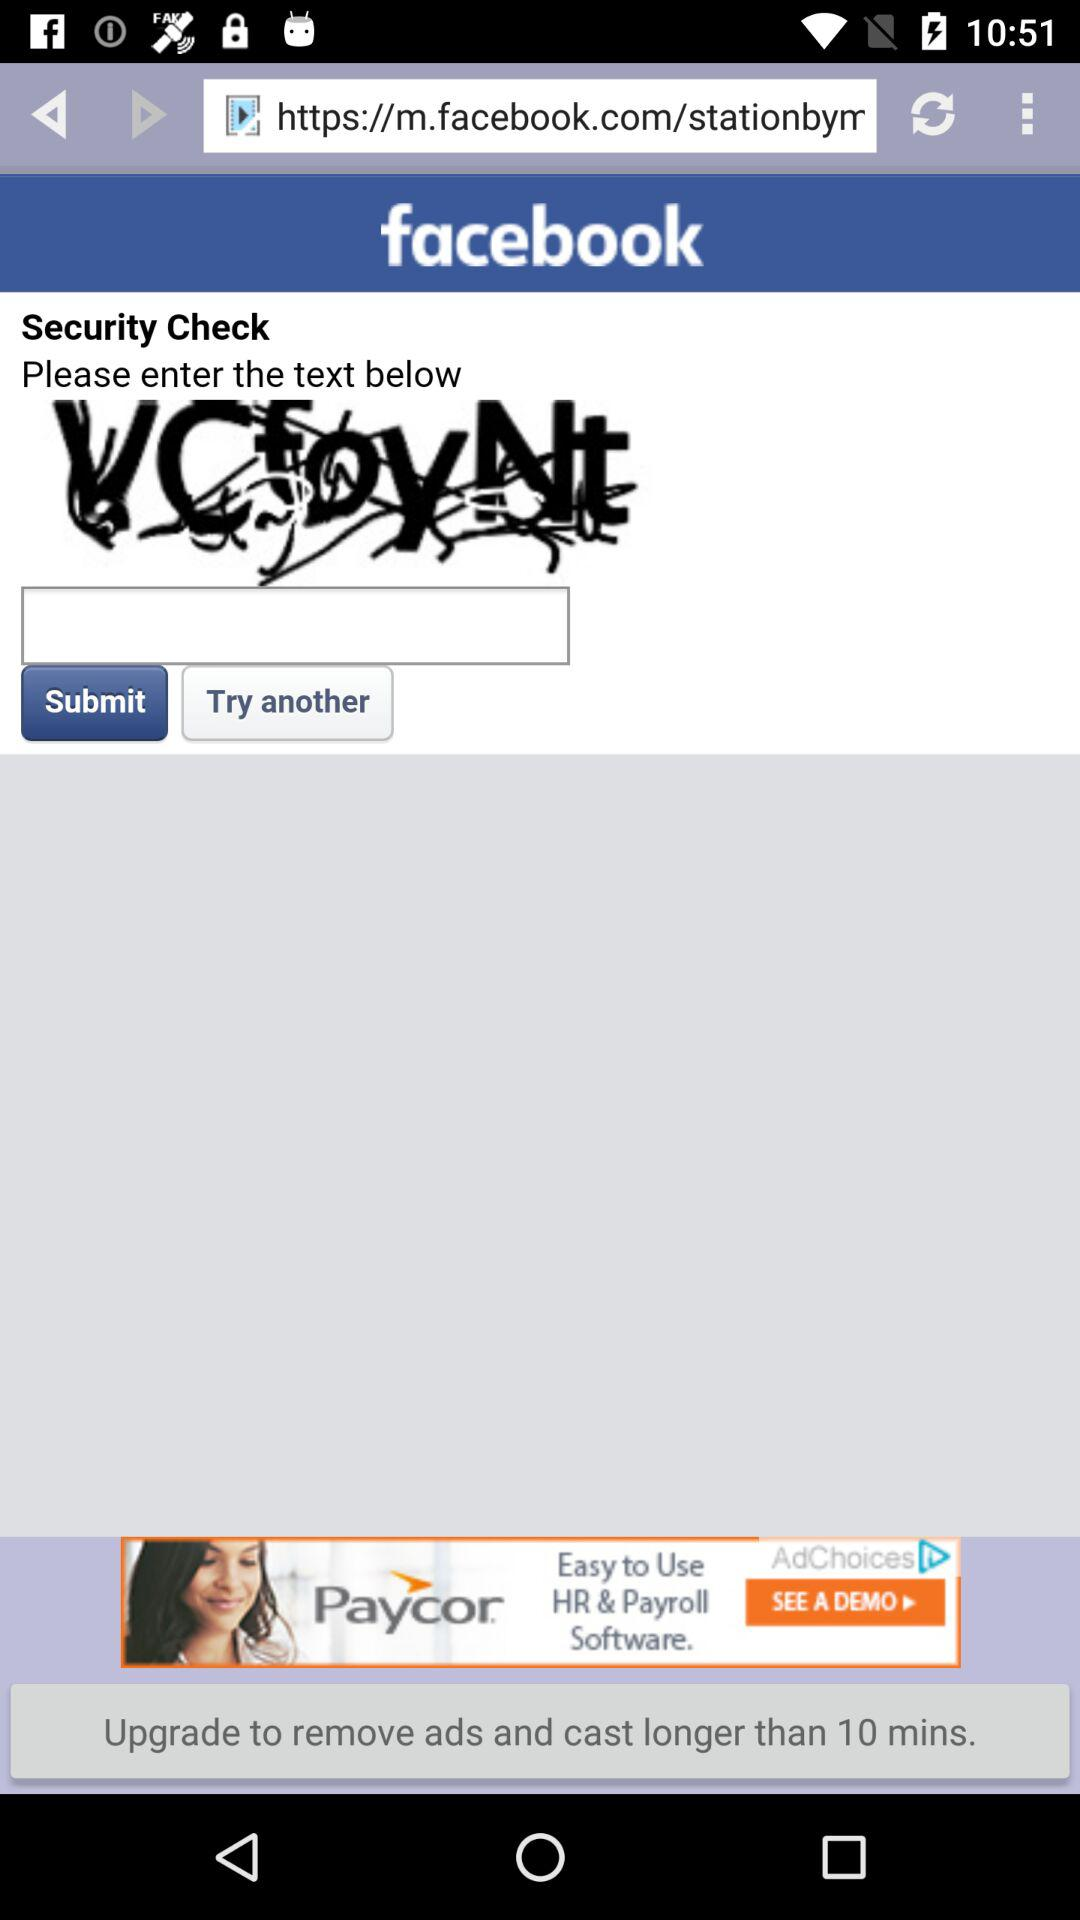What is the name of the application? The name of the application is "Facebook". 